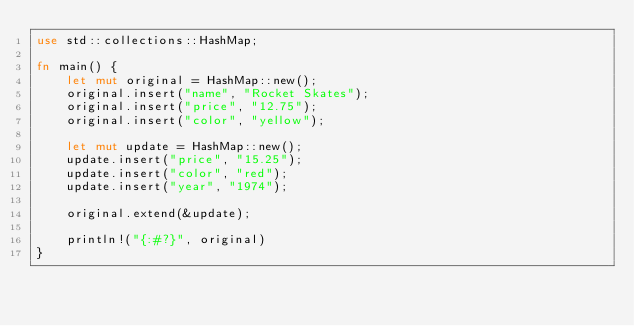Convert code to text. <code><loc_0><loc_0><loc_500><loc_500><_Rust_>use std::collections::HashMap;

fn main() {
    let mut original = HashMap::new();
    original.insert("name", "Rocket Skates");
    original.insert("price", "12.75");
    original.insert("color", "yellow");

    let mut update = HashMap::new();
    update.insert("price", "15.25");
    update.insert("color", "red");
    update.insert("year", "1974");

    original.extend(&update);

    println!("{:#?}", original)
}
</code> 